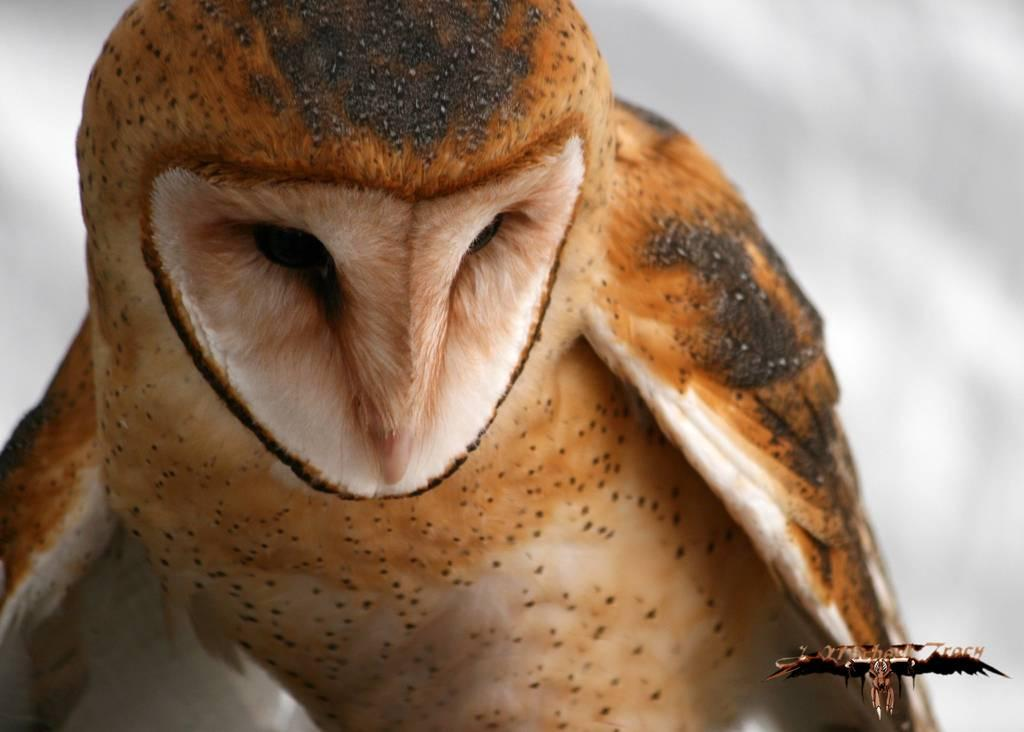What is the main subject in the foreground of the image? There is a bird in the foreground of the image. What is the bird doing in the image? The bird is looking at someone or something. What type of birthday celebration is happening in the image? There is no indication of a birthday celebration in the image; it features a bird looking at someone or something. Can you see the fang of the bird in the image? Birds do not have fangs, so there is no fang to be seen in the image. 